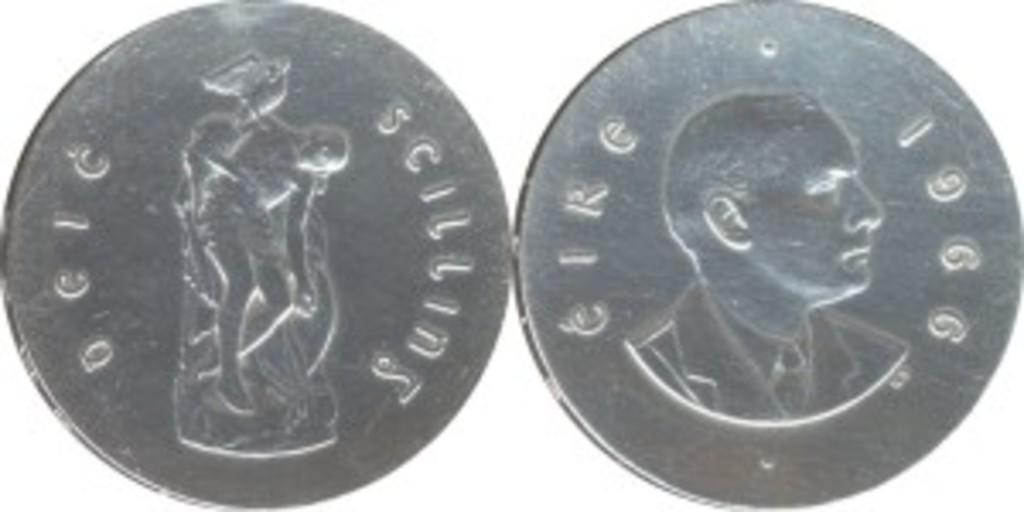What objects are present in the image? There are coins in the image. What color is the background of the image? The background of the image is white. What type of dinner is being served in the image? There is no dinner present in the image; it only features coins on a white background. 